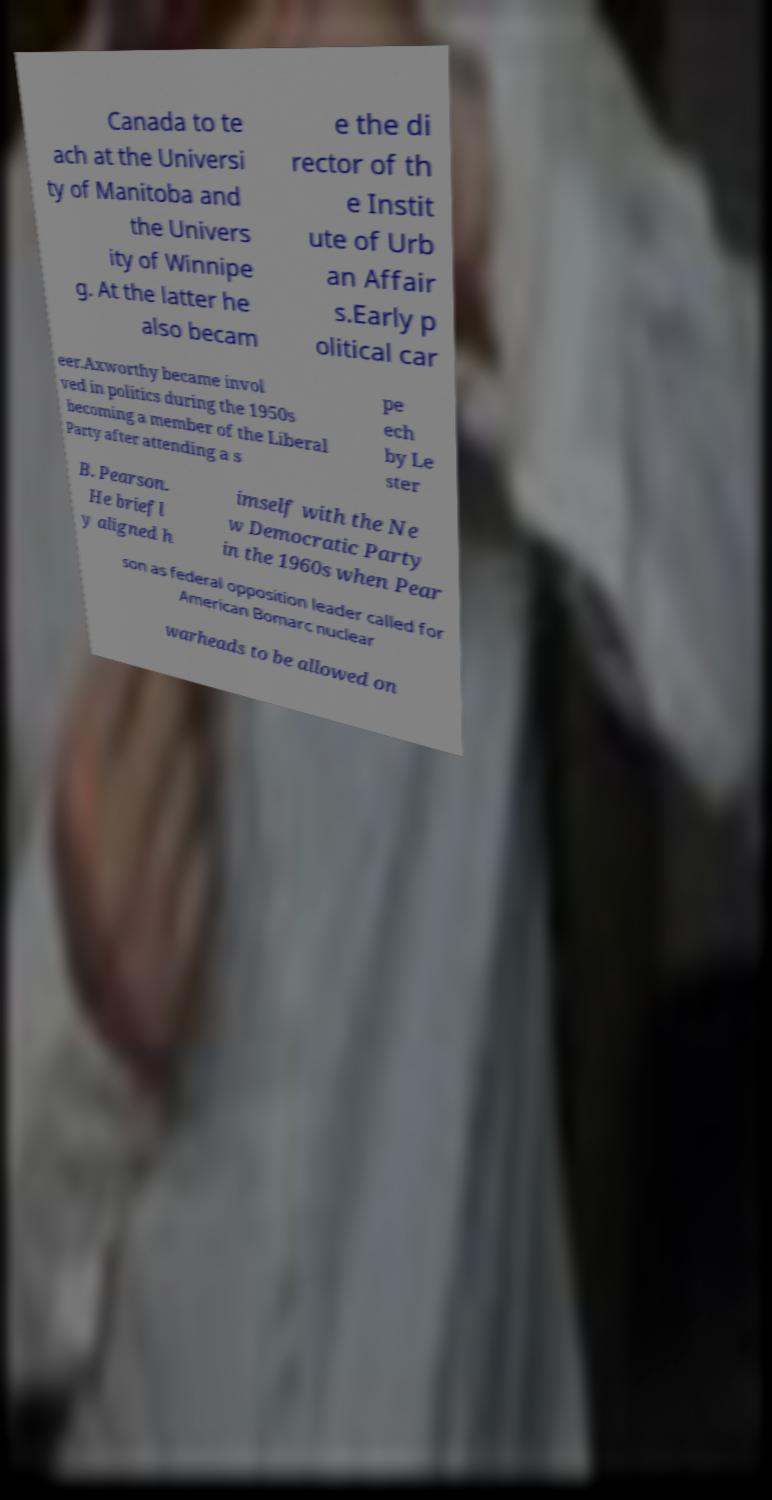Please read and relay the text visible in this image. What does it say? Canada to te ach at the Universi ty of Manitoba and the Univers ity of Winnipe g. At the latter he also becam e the di rector of th e Instit ute of Urb an Affair s.Early p olitical car eer.Axworthy became invol ved in politics during the 1950s becoming a member of the Liberal Party after attending a s pe ech by Le ster B. Pearson. He briefl y aligned h imself with the Ne w Democratic Party in the 1960s when Pear son as federal opposition leader called for American Bomarc nuclear warheads to be allowed on 